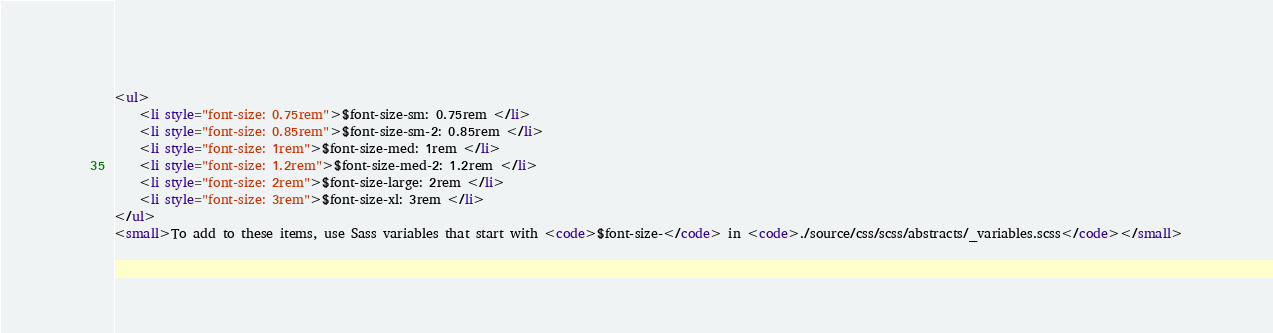<code> <loc_0><loc_0><loc_500><loc_500><_HTML_><ul>
    <li style="font-size: 0.75rem">$font-size-sm: 0.75rem </li>
    <li style="font-size: 0.85rem">$font-size-sm-2: 0.85rem </li>
    <li style="font-size: 1rem">$font-size-med: 1rem </li>
    <li style="font-size: 1.2rem">$font-size-med-2: 1.2rem </li>
    <li style="font-size: 2rem">$font-size-large: 2rem </li>
    <li style="font-size: 3rem">$font-size-xl: 3rem </li>
</ul>
<small>To add to these items, use Sass variables that start with <code>$font-size-</code> in <code>./source/css/scss/abstracts/_variables.scss</code></small></code> 